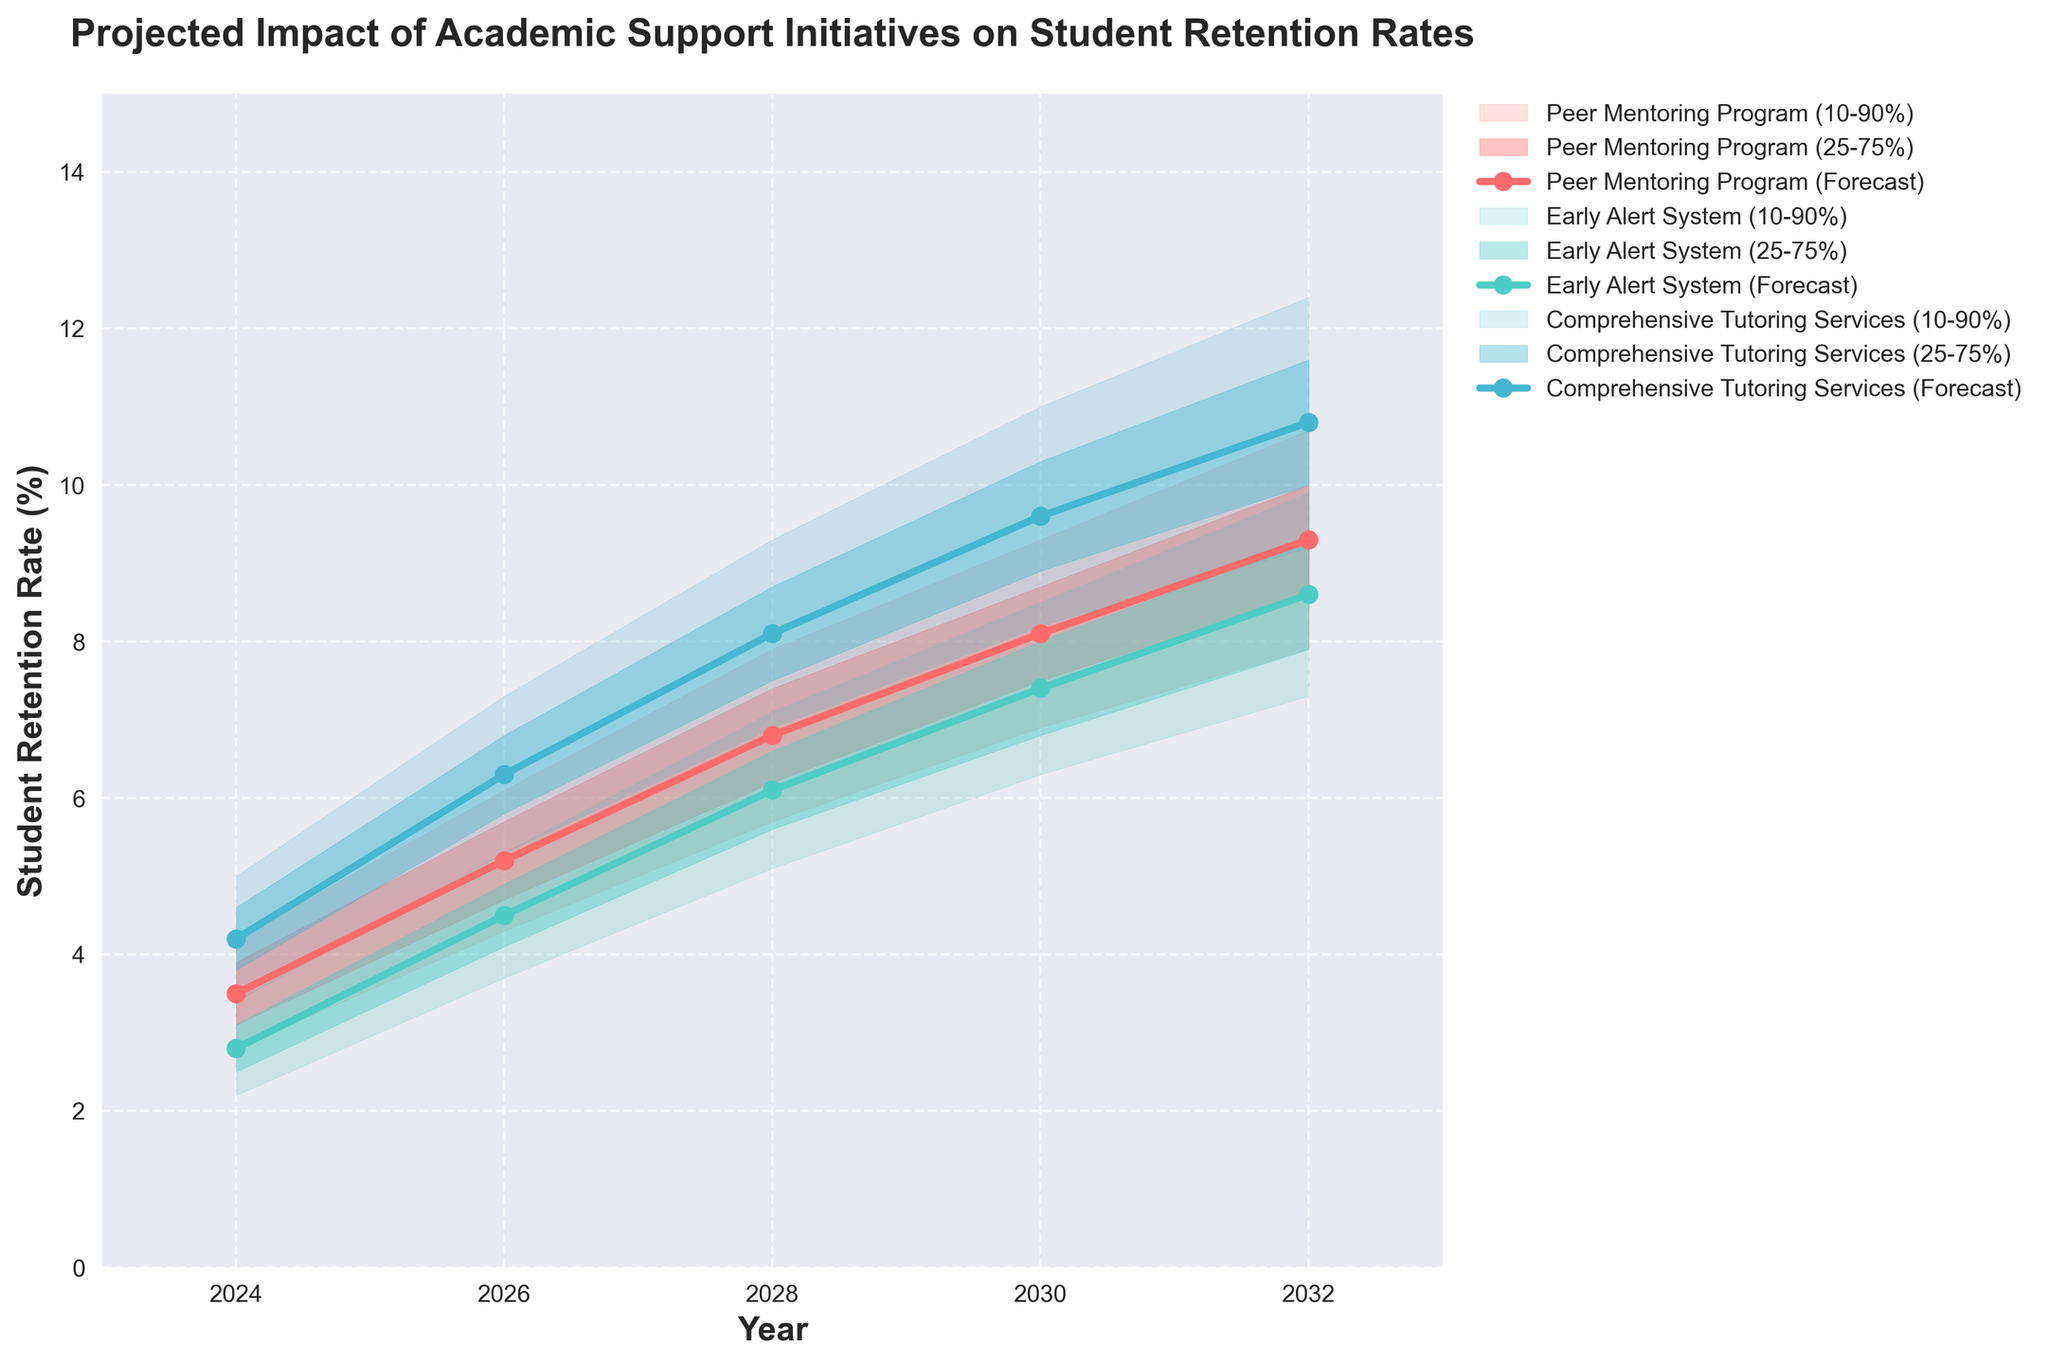What is the title of the chart? The title of the chart is located at the top and reads, "Projected Impact of Academic Support Initiatives on Student Retention Rates".
Answer: Projected Impact of Academic Support Initiatives on Student Retention Rates Which initiative shows the highest forecasted retention rate in 2032? By examining the forecasted retention rates for each initiative in 2032, it is clear that Comprehensive Tutoring Services has the highest forecasted retention rate at 10.8%.
Answer: Comprehensive Tutoring Services What are the lower and upper bounds of the 25-75% confidence interval for the Peer Mentoring Program in 2028? The 25-75% confidence interval for the Peer Mentoring Program in 2028 is between the lower 25% and upper 75% values. According to the chart, this interval ranges from 6.2% to 7.4%.
Answer: 6.2% to 7.4% How does the forecasted retention rate of the Early Alert System in 2030 compare to the Peer Mentoring Program in the same year? The forecasted retention rate for the Early Alert System in 2030 is 7.4%, while for the Peer Mentoring Program, it is 8.1%. Given these two values, the retention rate for the Peer Mentoring Program is higher.
Answer: The Peer Mentoring Program is higher What is the range of the 10-90% confidence interval for Comprehensive Tutoring Services in 2024? The 10-90% confidence interval range is calculated by subtracting the lower 10% value from the upper 90% value for Comprehensive Tutoring Services in 2024. The values are 5.0% and 3.4%, respectively, so 5.0% - 3.4% = 1.6%.
Answer: 1.6% Between which years do all initiatives show an upward trend in forecasted retention rates? Observing all initiatives' forecasted retention rates from 2024 to 2032, it is evident that all show an upward trend, meaning they increase over all the years within this period.
Answer: 2024 and 2032 Which initiative has the narrowest forecasted range (10-90% confidence interval) in 2024? By comparing the 10-90% confidence intervals for each initiative in 2024, the Early Alert System has the narrowest range, from 2.2% to 3.4%, giving a range of 1.2%.
Answer: Early Alert System What is the average forecasted retention rate for the Peer Mentoring Program across all the years shown? Calculating the average involves summing all the forecasted retention rates for the Peer Mentoring Program (3.5, 5.2, 6.8, 8.1, 9.3) and then dividing by the number of years, which is 5. This results in (3.5 + 5.2 + 6.8 + 8.1 + 9.3) / 5 = 6.58%.
Answer: 6.58% In which year does the Early Alert System surpass a forecasted retention rate of 6% for the first time? Reviewing the forecasted retention rates for the Early Alert System, it surpasses 6% in 2028, with a forecasted retention rate of 6.1%.
Answer: 2028 